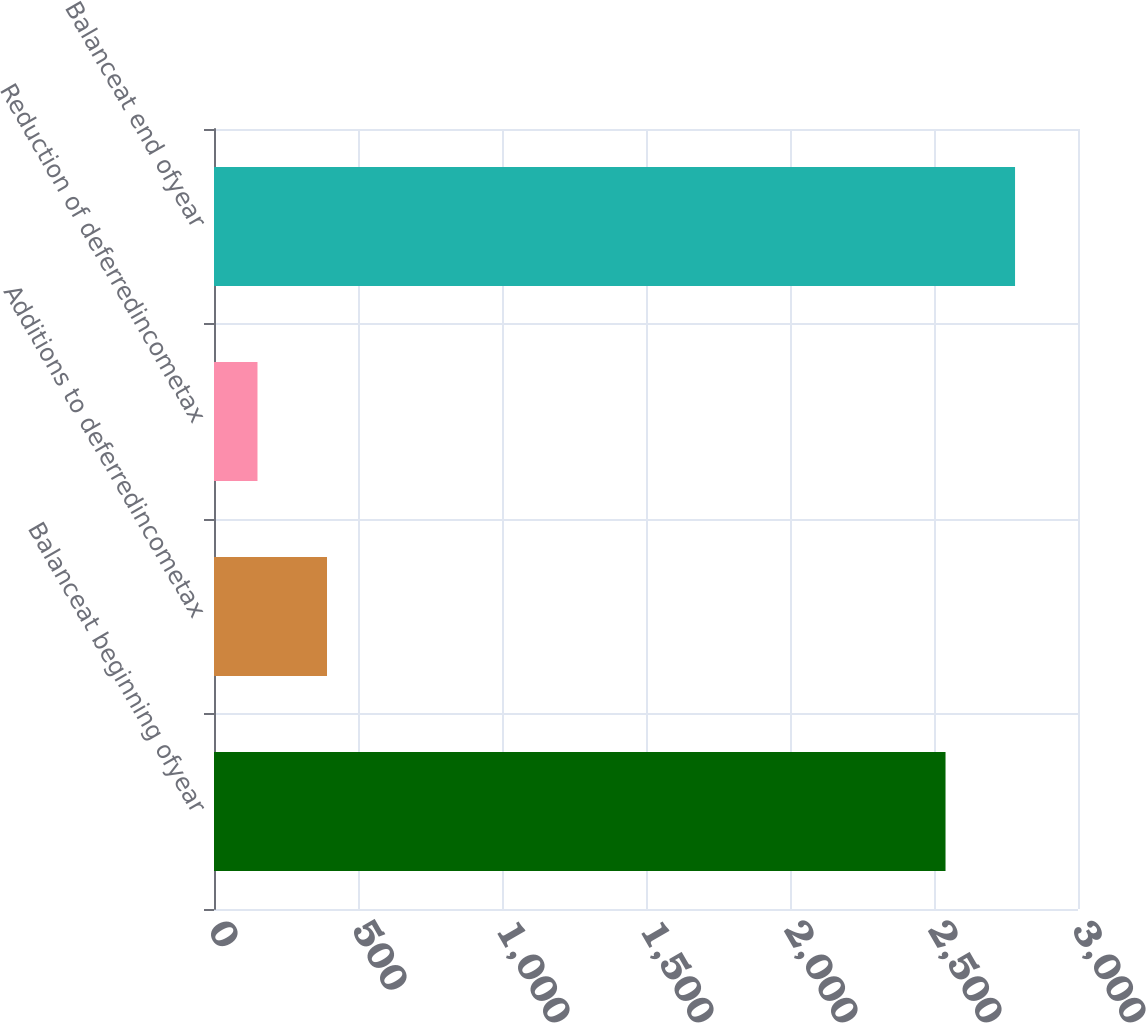Convert chart to OTSL. <chart><loc_0><loc_0><loc_500><loc_500><bar_chart><fcel>Balanceat beginning ofyear<fcel>Additions to deferredincometax<fcel>Reduction of deferredincometax<fcel>Balanceat end ofyear<nl><fcel>2540<fcel>392.4<fcel>151<fcel>2781.4<nl></chart> 